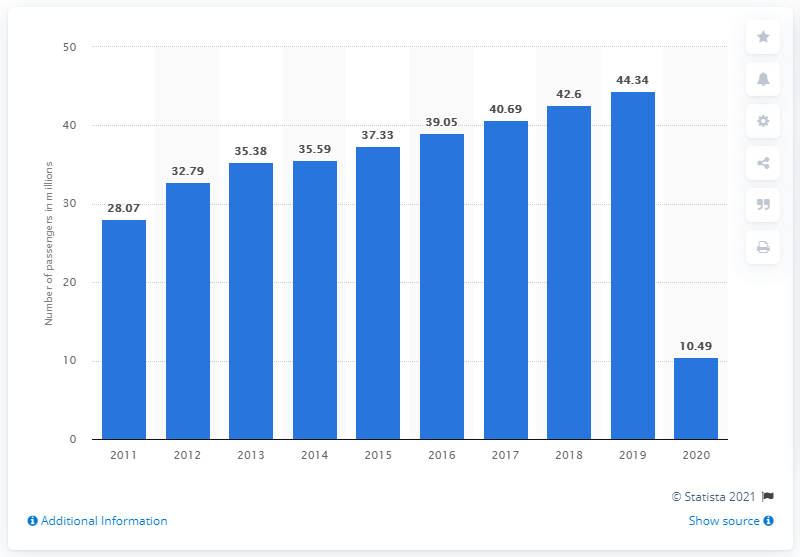Point out several critical features in this image. Narita International Airport handled a total of 10,490 terminal passengers in 2020. 